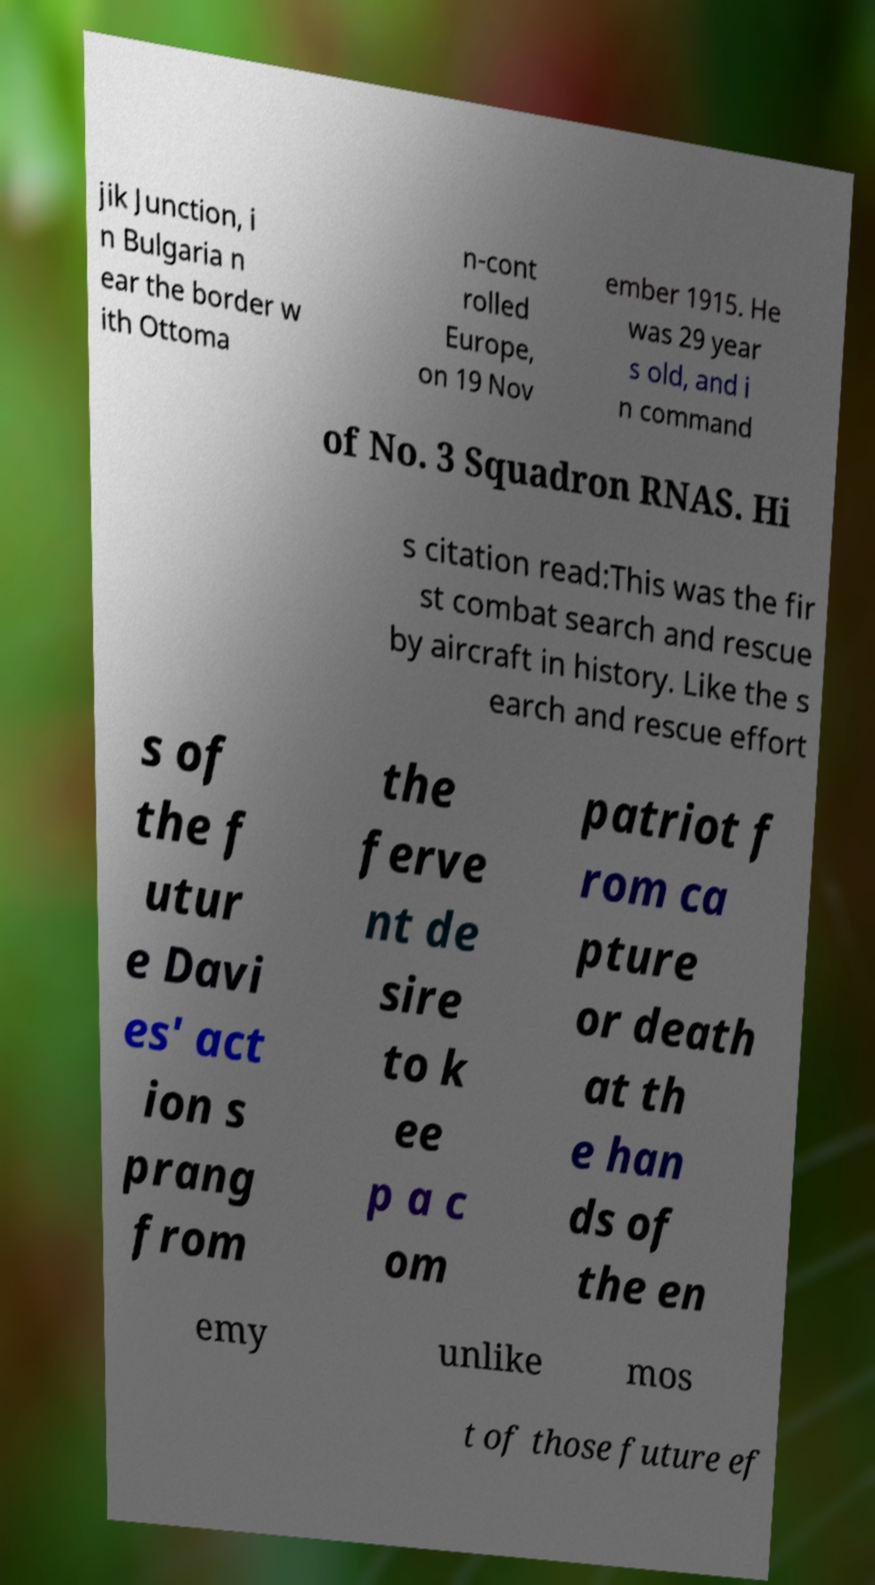Please read and relay the text visible in this image. What does it say? jik Junction, i n Bulgaria n ear the border w ith Ottoma n-cont rolled Europe, on 19 Nov ember 1915. He was 29 year s old, and i n command of No. 3 Squadron RNAS. Hi s citation read:This was the fir st combat search and rescue by aircraft in history. Like the s earch and rescue effort s of the f utur e Davi es' act ion s prang from the ferve nt de sire to k ee p a c om patriot f rom ca pture or death at th e han ds of the en emy unlike mos t of those future ef 